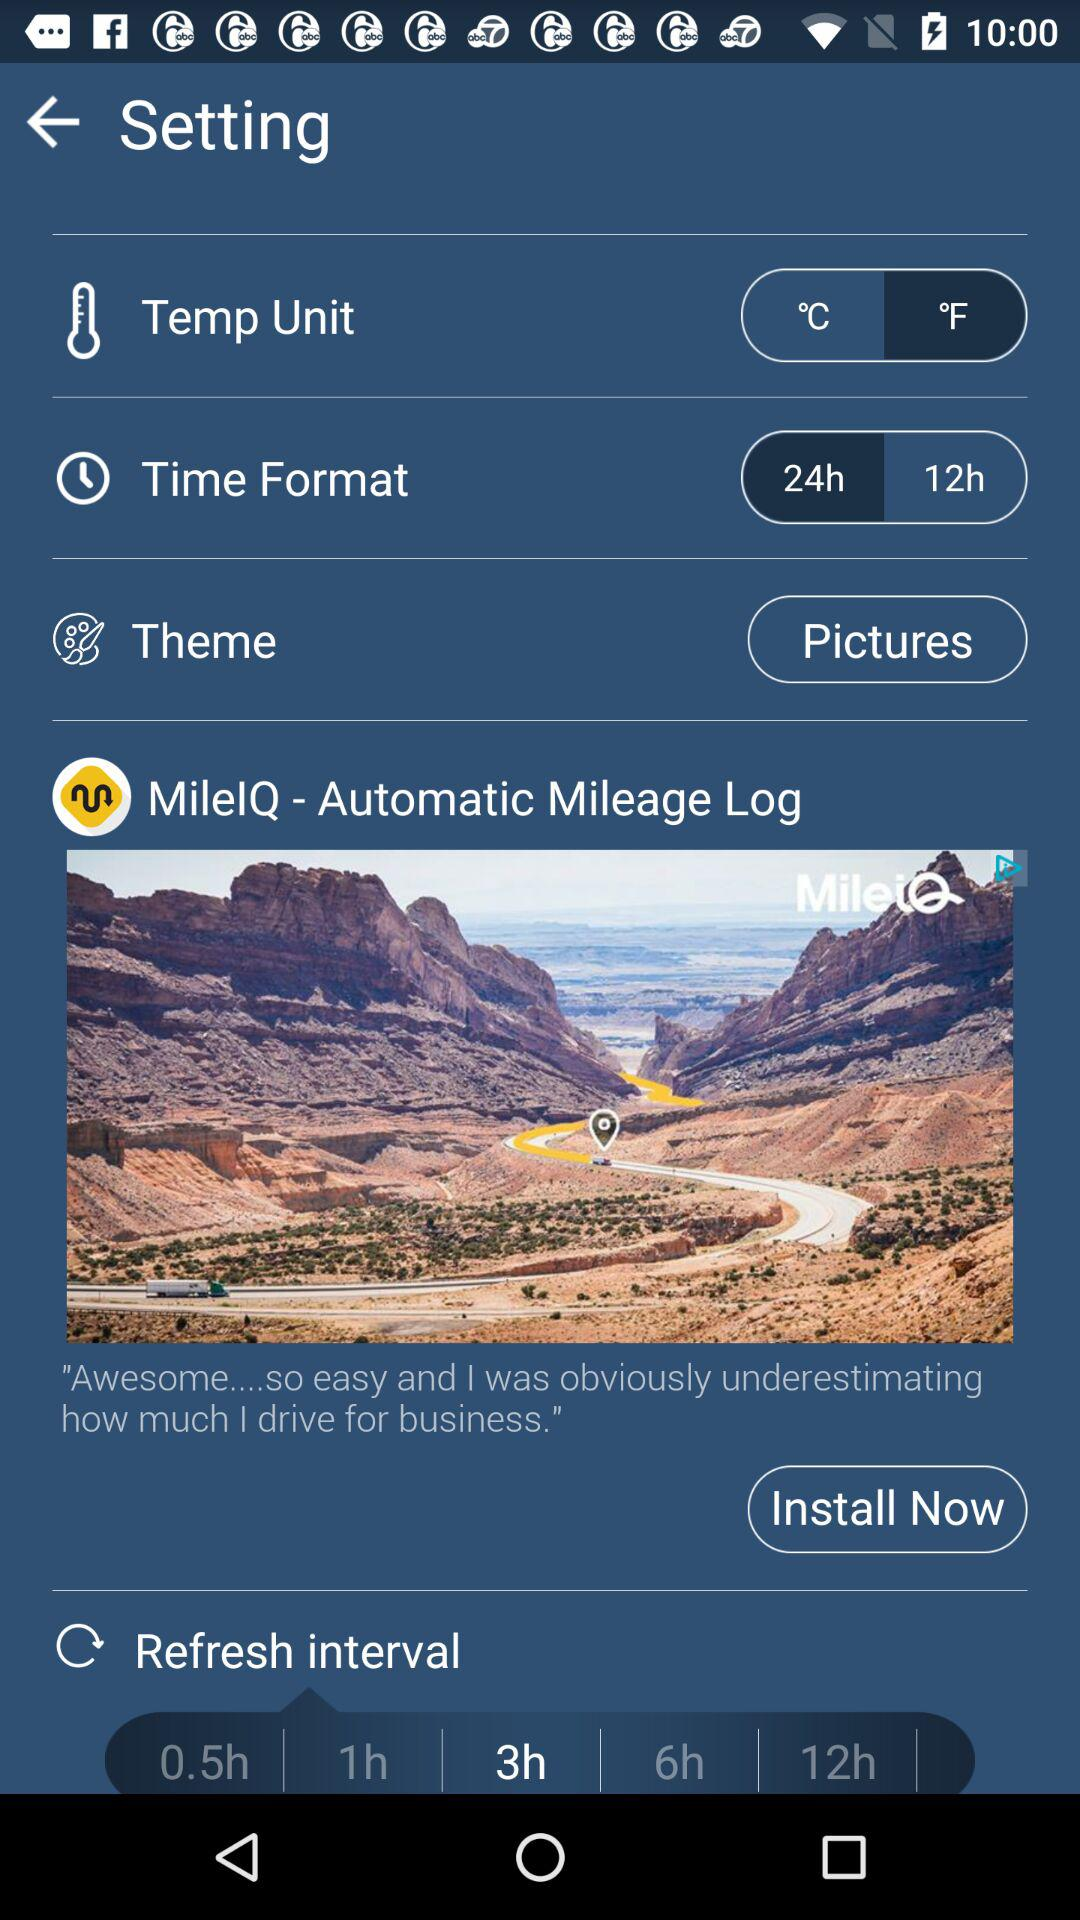Which time format is selected? The selected time format is 24 hours. 